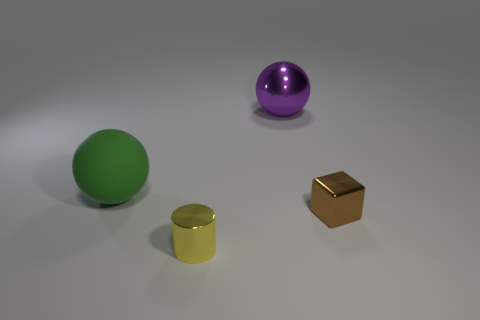Add 4 small brown spheres. How many objects exist? 8 Subtract all cubes. How many objects are left? 3 Subtract all brown things. Subtract all brown metal blocks. How many objects are left? 2 Add 2 green matte things. How many green matte things are left? 3 Add 1 large green rubber balls. How many large green rubber balls exist? 2 Subtract 0 gray balls. How many objects are left? 4 